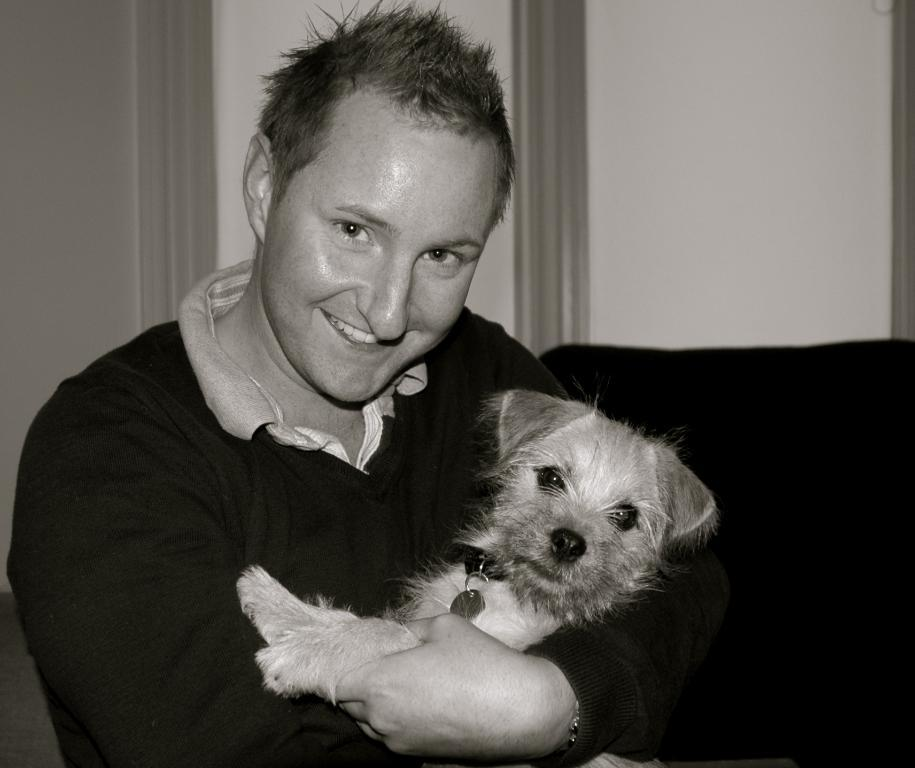What is the main subject of the image? The main subject of the image is a man. What is the man doing in the image? The man is holding a dog in the image. How does the man appear to feel in the image? The man has a smile on his face, which suggests he is happy or enjoying the moment. What type of art can be seen on the wall behind the man and dog? There is no mention of any art or wall in the provided facts, so it cannot be determined from the image. 